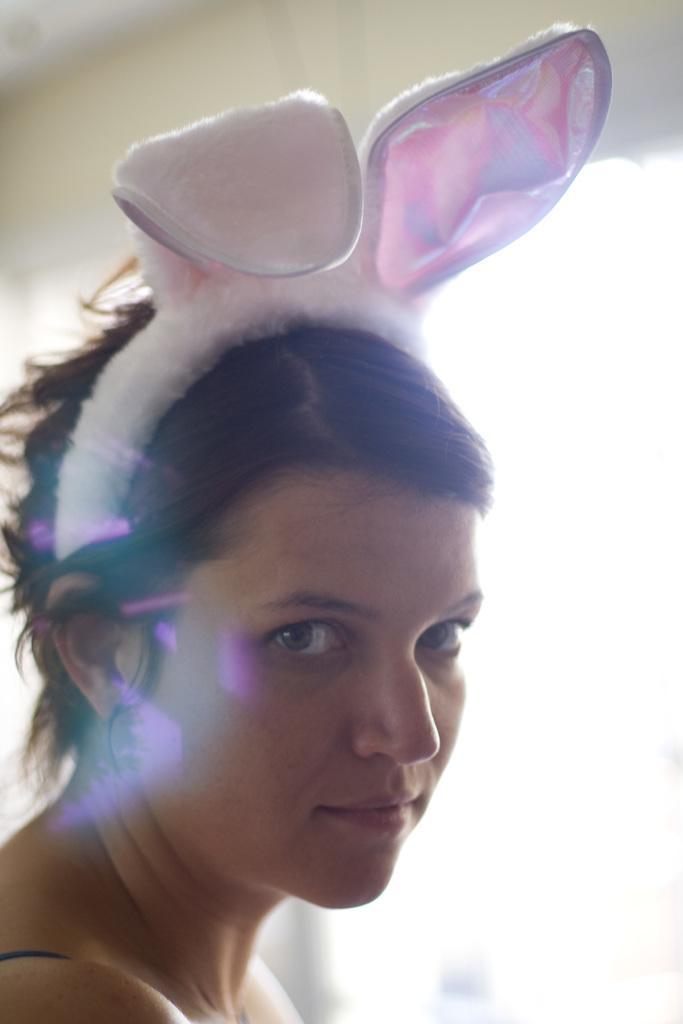Could you give a brief overview of what you see in this image? In this picture I can see a woman with a rabbit headband, and there is blur background. 